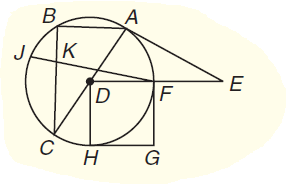Answer the mathemtical geometry problem and directly provide the correct option letter.
Question: Chords J F and B C intersect at K. If B K = 8, K C = 12, and K F = 16, find J K.
Choices: A: 6 B: 12 C: 15 D: 18 A 